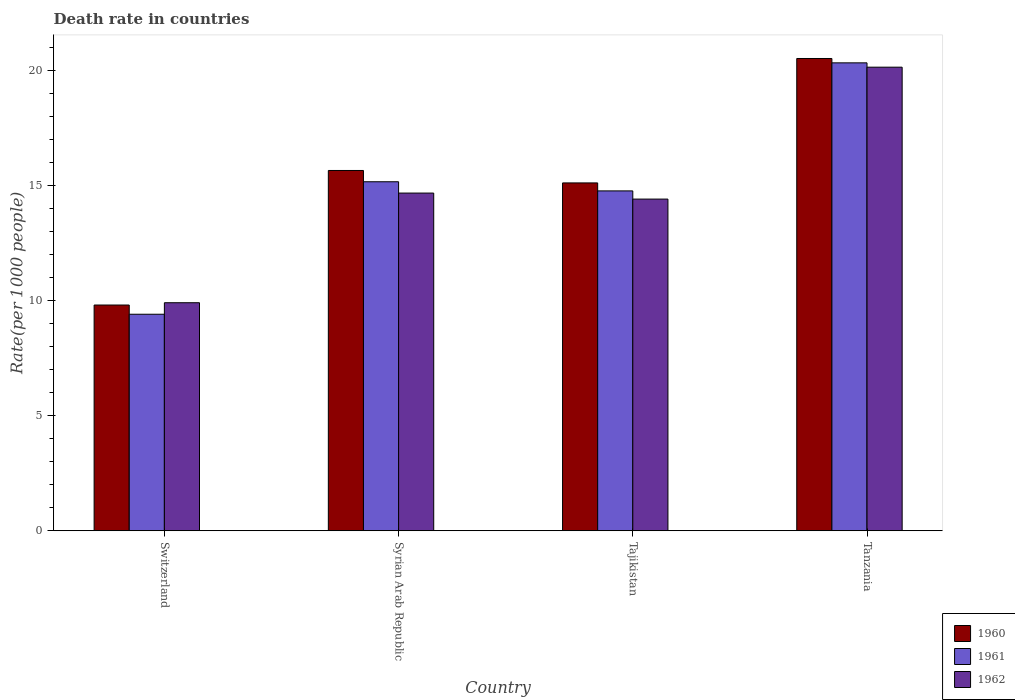How many different coloured bars are there?
Give a very brief answer. 3. How many groups of bars are there?
Offer a terse response. 4. Are the number of bars on each tick of the X-axis equal?
Offer a very short reply. Yes. What is the label of the 3rd group of bars from the left?
Provide a short and direct response. Tajikistan. What is the death rate in 1961 in Tajikistan?
Your response must be concise. 14.75. Across all countries, what is the maximum death rate in 1961?
Your answer should be compact. 20.31. Across all countries, what is the minimum death rate in 1962?
Offer a very short reply. 9.9. In which country was the death rate in 1961 maximum?
Your response must be concise. Tanzania. In which country was the death rate in 1961 minimum?
Offer a terse response. Switzerland. What is the total death rate in 1961 in the graph?
Your response must be concise. 59.62. What is the difference between the death rate in 1960 in Syrian Arab Republic and that in Tajikistan?
Your response must be concise. 0.54. What is the difference between the death rate in 1962 in Switzerland and the death rate in 1961 in Syrian Arab Republic?
Make the answer very short. -5.25. What is the average death rate in 1961 per country?
Provide a succinct answer. 14.9. What is the difference between the death rate of/in 1960 and death rate of/in 1962 in Tanzania?
Make the answer very short. 0.38. In how many countries, is the death rate in 1961 greater than 18?
Ensure brevity in your answer.  1. What is the ratio of the death rate in 1960 in Switzerland to that in Syrian Arab Republic?
Provide a succinct answer. 0.63. Is the death rate in 1960 in Tajikistan less than that in Tanzania?
Provide a short and direct response. Yes. Is the difference between the death rate in 1960 in Tajikistan and Tanzania greater than the difference between the death rate in 1962 in Tajikistan and Tanzania?
Make the answer very short. Yes. What is the difference between the highest and the second highest death rate in 1961?
Provide a short and direct response. 5.56. What is the difference between the highest and the lowest death rate in 1960?
Provide a succinct answer. 10.7. In how many countries, is the death rate in 1960 greater than the average death rate in 1960 taken over all countries?
Offer a very short reply. 2. What does the 3rd bar from the left in Tanzania represents?
Your response must be concise. 1962. What does the 2nd bar from the right in Syrian Arab Republic represents?
Offer a terse response. 1961. How many countries are there in the graph?
Your answer should be very brief. 4. Are the values on the major ticks of Y-axis written in scientific E-notation?
Give a very brief answer. No. What is the title of the graph?
Offer a terse response. Death rate in countries. What is the label or title of the X-axis?
Your response must be concise. Country. What is the label or title of the Y-axis?
Keep it short and to the point. Rate(per 1000 people). What is the Rate(per 1000 people) in 1962 in Switzerland?
Offer a very short reply. 9.9. What is the Rate(per 1000 people) in 1960 in Syrian Arab Republic?
Provide a short and direct response. 15.64. What is the Rate(per 1000 people) in 1961 in Syrian Arab Republic?
Offer a very short reply. 15.15. What is the Rate(per 1000 people) of 1962 in Syrian Arab Republic?
Your response must be concise. 14.66. What is the Rate(per 1000 people) in 1960 in Tajikistan?
Keep it short and to the point. 15.1. What is the Rate(per 1000 people) in 1961 in Tajikistan?
Provide a short and direct response. 14.75. What is the Rate(per 1000 people) in 1962 in Tajikistan?
Offer a very short reply. 14.4. What is the Rate(per 1000 people) in 1960 in Tanzania?
Ensure brevity in your answer.  20.5. What is the Rate(per 1000 people) of 1961 in Tanzania?
Keep it short and to the point. 20.31. What is the Rate(per 1000 people) in 1962 in Tanzania?
Provide a succinct answer. 20.12. Across all countries, what is the maximum Rate(per 1000 people) in 1960?
Your answer should be very brief. 20.5. Across all countries, what is the maximum Rate(per 1000 people) of 1961?
Your answer should be compact. 20.31. Across all countries, what is the maximum Rate(per 1000 people) of 1962?
Ensure brevity in your answer.  20.12. Across all countries, what is the minimum Rate(per 1000 people) of 1960?
Provide a succinct answer. 9.8. Across all countries, what is the minimum Rate(per 1000 people) of 1962?
Provide a succinct answer. 9.9. What is the total Rate(per 1000 people) in 1960 in the graph?
Your answer should be very brief. 61.04. What is the total Rate(per 1000 people) of 1961 in the graph?
Provide a succinct answer. 59.62. What is the total Rate(per 1000 people) in 1962 in the graph?
Offer a very short reply. 59.08. What is the difference between the Rate(per 1000 people) in 1960 in Switzerland and that in Syrian Arab Republic?
Give a very brief answer. -5.84. What is the difference between the Rate(per 1000 people) in 1961 in Switzerland and that in Syrian Arab Republic?
Ensure brevity in your answer.  -5.75. What is the difference between the Rate(per 1000 people) in 1962 in Switzerland and that in Syrian Arab Republic?
Provide a short and direct response. -4.76. What is the difference between the Rate(per 1000 people) of 1960 in Switzerland and that in Tajikistan?
Your answer should be compact. -5.3. What is the difference between the Rate(per 1000 people) of 1961 in Switzerland and that in Tajikistan?
Offer a very short reply. -5.35. What is the difference between the Rate(per 1000 people) in 1962 in Switzerland and that in Tajikistan?
Keep it short and to the point. -4.5. What is the difference between the Rate(per 1000 people) of 1960 in Switzerland and that in Tanzania?
Your response must be concise. -10.7. What is the difference between the Rate(per 1000 people) in 1961 in Switzerland and that in Tanzania?
Your answer should be compact. -10.91. What is the difference between the Rate(per 1000 people) in 1962 in Switzerland and that in Tanzania?
Give a very brief answer. -10.22. What is the difference between the Rate(per 1000 people) in 1960 in Syrian Arab Republic and that in Tajikistan?
Provide a short and direct response. 0.54. What is the difference between the Rate(per 1000 people) of 1961 in Syrian Arab Republic and that in Tajikistan?
Ensure brevity in your answer.  0.4. What is the difference between the Rate(per 1000 people) in 1962 in Syrian Arab Republic and that in Tajikistan?
Provide a short and direct response. 0.26. What is the difference between the Rate(per 1000 people) of 1960 in Syrian Arab Republic and that in Tanzania?
Make the answer very short. -4.86. What is the difference between the Rate(per 1000 people) in 1961 in Syrian Arab Republic and that in Tanzania?
Your answer should be very brief. -5.16. What is the difference between the Rate(per 1000 people) of 1962 in Syrian Arab Republic and that in Tanzania?
Ensure brevity in your answer.  -5.46. What is the difference between the Rate(per 1000 people) of 1960 in Tajikistan and that in Tanzania?
Offer a terse response. -5.4. What is the difference between the Rate(per 1000 people) in 1961 in Tajikistan and that in Tanzania?
Keep it short and to the point. -5.56. What is the difference between the Rate(per 1000 people) in 1962 in Tajikistan and that in Tanzania?
Ensure brevity in your answer.  -5.73. What is the difference between the Rate(per 1000 people) of 1960 in Switzerland and the Rate(per 1000 people) of 1961 in Syrian Arab Republic?
Keep it short and to the point. -5.35. What is the difference between the Rate(per 1000 people) of 1960 in Switzerland and the Rate(per 1000 people) of 1962 in Syrian Arab Republic?
Provide a succinct answer. -4.86. What is the difference between the Rate(per 1000 people) in 1961 in Switzerland and the Rate(per 1000 people) in 1962 in Syrian Arab Republic?
Make the answer very short. -5.26. What is the difference between the Rate(per 1000 people) of 1960 in Switzerland and the Rate(per 1000 people) of 1961 in Tajikistan?
Provide a short and direct response. -4.95. What is the difference between the Rate(per 1000 people) in 1960 in Switzerland and the Rate(per 1000 people) in 1962 in Tajikistan?
Your response must be concise. -4.6. What is the difference between the Rate(per 1000 people) of 1961 in Switzerland and the Rate(per 1000 people) of 1962 in Tajikistan?
Give a very brief answer. -5. What is the difference between the Rate(per 1000 people) in 1960 in Switzerland and the Rate(per 1000 people) in 1961 in Tanzania?
Your response must be concise. -10.51. What is the difference between the Rate(per 1000 people) of 1960 in Switzerland and the Rate(per 1000 people) of 1962 in Tanzania?
Offer a very short reply. -10.32. What is the difference between the Rate(per 1000 people) in 1961 in Switzerland and the Rate(per 1000 people) in 1962 in Tanzania?
Provide a succinct answer. -10.72. What is the difference between the Rate(per 1000 people) of 1960 in Syrian Arab Republic and the Rate(per 1000 people) of 1961 in Tajikistan?
Ensure brevity in your answer.  0.89. What is the difference between the Rate(per 1000 people) in 1960 in Syrian Arab Republic and the Rate(per 1000 people) in 1962 in Tajikistan?
Your response must be concise. 1.24. What is the difference between the Rate(per 1000 people) of 1961 in Syrian Arab Republic and the Rate(per 1000 people) of 1962 in Tajikistan?
Provide a succinct answer. 0.75. What is the difference between the Rate(per 1000 people) in 1960 in Syrian Arab Republic and the Rate(per 1000 people) in 1961 in Tanzania?
Provide a short and direct response. -4.67. What is the difference between the Rate(per 1000 people) in 1960 in Syrian Arab Republic and the Rate(per 1000 people) in 1962 in Tanzania?
Offer a very short reply. -4.48. What is the difference between the Rate(per 1000 people) in 1961 in Syrian Arab Republic and the Rate(per 1000 people) in 1962 in Tanzania?
Your answer should be compact. -4.97. What is the difference between the Rate(per 1000 people) in 1960 in Tajikistan and the Rate(per 1000 people) in 1961 in Tanzania?
Make the answer very short. -5.21. What is the difference between the Rate(per 1000 people) in 1960 in Tajikistan and the Rate(per 1000 people) in 1962 in Tanzania?
Offer a terse response. -5.02. What is the difference between the Rate(per 1000 people) of 1961 in Tajikistan and the Rate(per 1000 people) of 1962 in Tanzania?
Give a very brief answer. -5.37. What is the average Rate(per 1000 people) in 1960 per country?
Provide a short and direct response. 15.26. What is the average Rate(per 1000 people) of 1961 per country?
Ensure brevity in your answer.  14.9. What is the average Rate(per 1000 people) of 1962 per country?
Offer a very short reply. 14.77. What is the difference between the Rate(per 1000 people) in 1960 and Rate(per 1000 people) in 1961 in Syrian Arab Republic?
Give a very brief answer. 0.49. What is the difference between the Rate(per 1000 people) in 1961 and Rate(per 1000 people) in 1962 in Syrian Arab Republic?
Give a very brief answer. 0.49. What is the difference between the Rate(per 1000 people) in 1960 and Rate(per 1000 people) in 1961 in Tajikistan?
Provide a short and direct response. 0.35. What is the difference between the Rate(per 1000 people) of 1960 and Rate(per 1000 people) of 1962 in Tajikistan?
Your response must be concise. 0.7. What is the difference between the Rate(per 1000 people) in 1961 and Rate(per 1000 people) in 1962 in Tajikistan?
Give a very brief answer. 0.35. What is the difference between the Rate(per 1000 people) of 1960 and Rate(per 1000 people) of 1961 in Tanzania?
Ensure brevity in your answer.  0.19. What is the difference between the Rate(per 1000 people) in 1960 and Rate(per 1000 people) in 1962 in Tanzania?
Offer a very short reply. 0.38. What is the difference between the Rate(per 1000 people) in 1961 and Rate(per 1000 people) in 1962 in Tanzania?
Your response must be concise. 0.19. What is the ratio of the Rate(per 1000 people) in 1960 in Switzerland to that in Syrian Arab Republic?
Your answer should be very brief. 0.63. What is the ratio of the Rate(per 1000 people) in 1961 in Switzerland to that in Syrian Arab Republic?
Offer a very short reply. 0.62. What is the ratio of the Rate(per 1000 people) of 1962 in Switzerland to that in Syrian Arab Republic?
Make the answer very short. 0.68. What is the ratio of the Rate(per 1000 people) of 1960 in Switzerland to that in Tajikistan?
Your answer should be compact. 0.65. What is the ratio of the Rate(per 1000 people) of 1961 in Switzerland to that in Tajikistan?
Give a very brief answer. 0.64. What is the ratio of the Rate(per 1000 people) in 1962 in Switzerland to that in Tajikistan?
Give a very brief answer. 0.69. What is the ratio of the Rate(per 1000 people) in 1960 in Switzerland to that in Tanzania?
Provide a short and direct response. 0.48. What is the ratio of the Rate(per 1000 people) of 1961 in Switzerland to that in Tanzania?
Keep it short and to the point. 0.46. What is the ratio of the Rate(per 1000 people) of 1962 in Switzerland to that in Tanzania?
Make the answer very short. 0.49. What is the ratio of the Rate(per 1000 people) in 1960 in Syrian Arab Republic to that in Tajikistan?
Your answer should be very brief. 1.04. What is the ratio of the Rate(per 1000 people) in 1961 in Syrian Arab Republic to that in Tajikistan?
Offer a very short reply. 1.03. What is the ratio of the Rate(per 1000 people) in 1962 in Syrian Arab Republic to that in Tajikistan?
Make the answer very short. 1.02. What is the ratio of the Rate(per 1000 people) of 1960 in Syrian Arab Republic to that in Tanzania?
Your answer should be compact. 0.76. What is the ratio of the Rate(per 1000 people) in 1961 in Syrian Arab Republic to that in Tanzania?
Give a very brief answer. 0.75. What is the ratio of the Rate(per 1000 people) of 1962 in Syrian Arab Republic to that in Tanzania?
Provide a succinct answer. 0.73. What is the ratio of the Rate(per 1000 people) in 1960 in Tajikistan to that in Tanzania?
Give a very brief answer. 0.74. What is the ratio of the Rate(per 1000 people) in 1961 in Tajikistan to that in Tanzania?
Ensure brevity in your answer.  0.73. What is the ratio of the Rate(per 1000 people) of 1962 in Tajikistan to that in Tanzania?
Make the answer very short. 0.72. What is the difference between the highest and the second highest Rate(per 1000 people) in 1960?
Keep it short and to the point. 4.86. What is the difference between the highest and the second highest Rate(per 1000 people) in 1961?
Your answer should be compact. 5.16. What is the difference between the highest and the second highest Rate(per 1000 people) of 1962?
Give a very brief answer. 5.46. What is the difference between the highest and the lowest Rate(per 1000 people) of 1960?
Provide a short and direct response. 10.7. What is the difference between the highest and the lowest Rate(per 1000 people) in 1961?
Your response must be concise. 10.91. What is the difference between the highest and the lowest Rate(per 1000 people) in 1962?
Your answer should be compact. 10.22. 